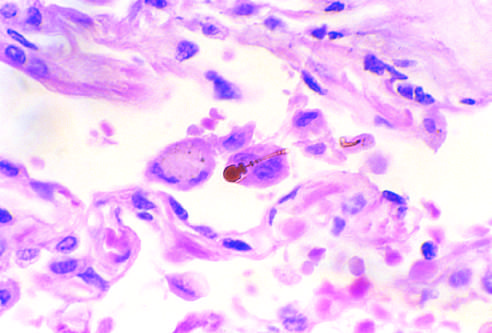what reveals the typical beading and knobbed ends?
Answer the question using a single word or phrase. High-power detail of an asbestos body 